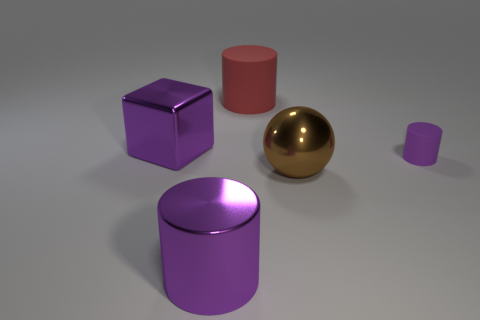Add 3 metal things. How many objects exist? 8 Subtract all cylinders. How many objects are left? 2 Add 4 large things. How many large things are left? 8 Add 4 tiny purple cylinders. How many tiny purple cylinders exist? 5 Subtract 0 yellow cylinders. How many objects are left? 5 Subtract all large blue shiny blocks. Subtract all big purple shiny blocks. How many objects are left? 4 